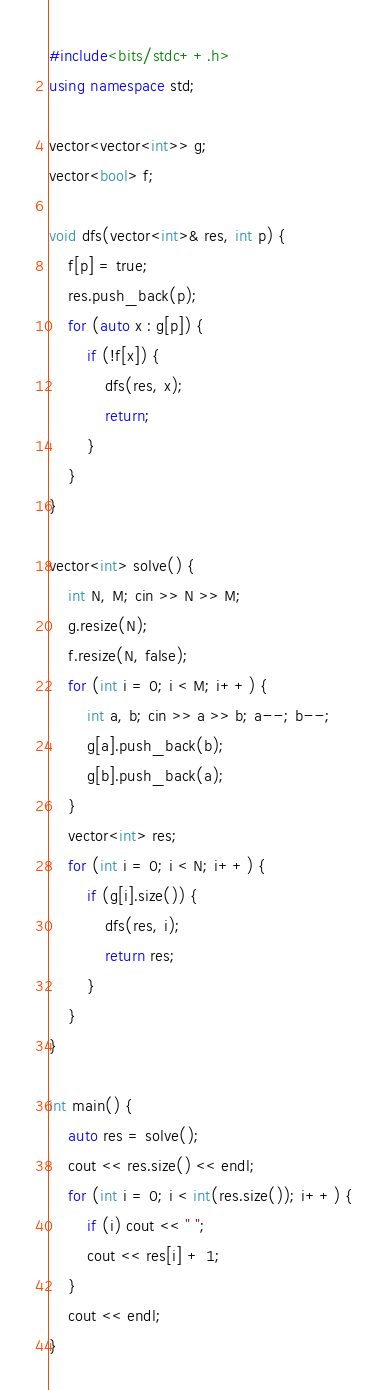Convert code to text. <code><loc_0><loc_0><loc_500><loc_500><_C++_>#include<bits/stdc++.h>
using namespace std;

vector<vector<int>> g;
vector<bool> f;

void dfs(vector<int>& res, int p) {
	f[p] = true;
	res.push_back(p);
	for (auto x : g[p]) {
		if (!f[x]) {
			dfs(res, x);
			return;
		}
	}
}

vector<int> solve() {
	int N, M; cin >> N >> M;
	g.resize(N);
	f.resize(N, false);
	for (int i = 0; i < M; i++) {
		int a, b; cin >> a >> b; a--; b--;
		g[a].push_back(b);
		g[b].push_back(a);
	}
	vector<int> res;
	for (int i = 0; i < N; i++) {
		if (g[i].size()) {
			dfs(res, i);
			return res;
		}
	}
}

int main() {
	auto res = solve();
	cout << res.size() << endl;
	for (int i = 0; i < int(res.size()); i++) {
		if (i) cout << " ";
		cout << res[i] + 1;
	}
	cout << endl;
}</code> 